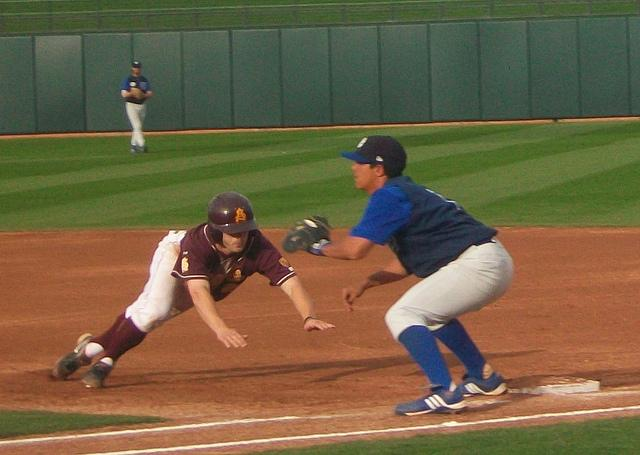What shapes are in the grass? rectangles 